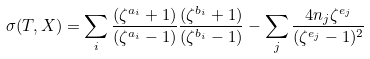Convert formula to latex. <formula><loc_0><loc_0><loc_500><loc_500>\sigma ( T , X ) = \sum _ { i } \frac { ( \zeta ^ { a _ { i } } + 1 ) } { ( \zeta ^ { a _ { i } } - 1 ) } \frac { ( \zeta ^ { b _ { i } } + 1 ) } { ( \zeta ^ { b _ { i } } - 1 ) } - \sum _ { j } \frac { 4 n _ { j } \zeta ^ { e _ { j } } } { ( \zeta ^ { e _ { j } } - 1 ) ^ { 2 } }</formula> 